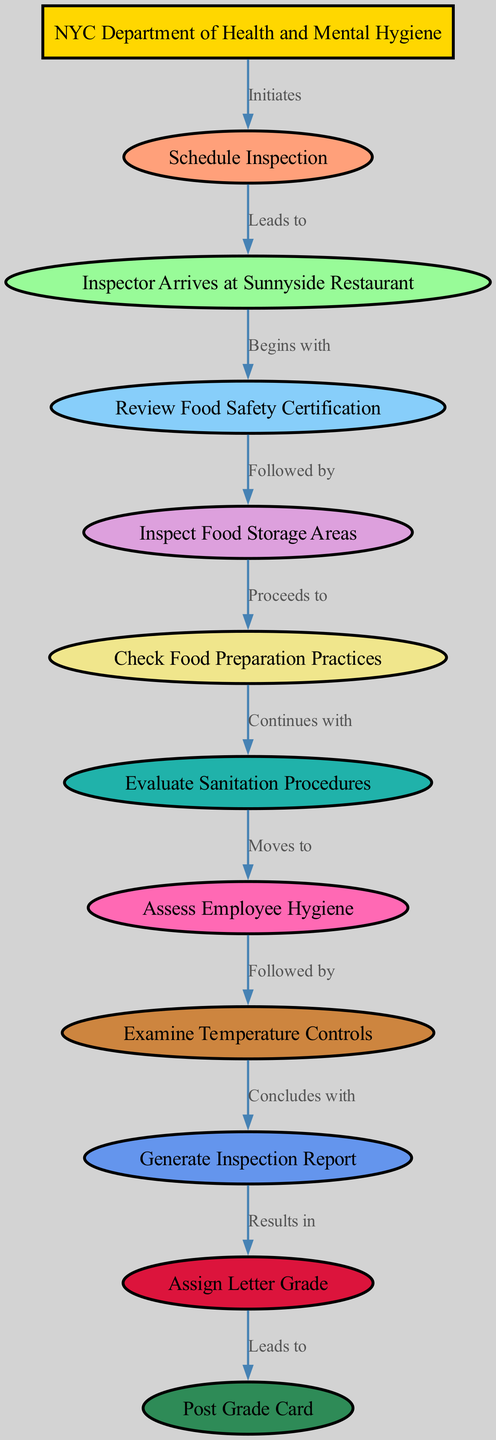What is the first step in the health inspection process? The first step, indicated by the node "Schedule Inspection," is outlined as the first action taken by the NYC Department of Health and Mental Hygiene.
Answer: Schedule Inspection How many nodes are there in the diagram? By counting each unique element represented in the nodes, we find that there are 12 nodes total in the diagram.
Answer: 12 Which node follows "Inspector Arrives at Sunnyside Restaurant"? Following "Inspector Arrives at Sunnyside Restaurant," the next step is "Review Food Safety Certification," connecting the two in sequential order in the process.
Answer: Review Food Safety Certification What type of procedure does the inspector evaluate after checking food preparation practices? After inspecting food preparation practices, the next procedure evaluated is "Evaluate Sanitation Procedures," indicating the inspector's continued assessment of the restaurant's hygiene standards.
Answer: Evaluate Sanitation Procedures What is the last action taken in the inspection process? The final action in the process, following the generation of the inspection report, is to "Post Grade Card," representing the conclusion of the health inspection process.
Answer: Post Grade Card Which node is responsible for generating the inspection report? The node that is responsible for generating the inspection report is "Generate Inspection Report," which captures all findings and outcomes before assigning a letter grade.
Answer: Generate Inspection Report What grades can result from the inspection process? The inspection process results in an "Assign Letter Grade," with potential grades ranging from A to C based on health standards met or violated during the inspection.
Answer: Assign Letter Grade What does "Examine Temperature Controls" relate to in the process? The "Examine Temperature Controls" node follows "Assess Employee Hygiene" and leads to the concluding step of generating the inspection report, underscoring the critical aspects of food safety.
Answer: Examine Temperature Controls Which node indicates the initiation of the health inspection? The initiation of the health inspection is indicated by the node "NYC Department of Health and Mental Hygiene," which initiates the entire process of restaurant health inspections.
Answer: NYC Department of Health and Mental Hygiene 